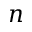Convert formula to latex. <formula><loc_0><loc_0><loc_500><loc_500>n</formula> 